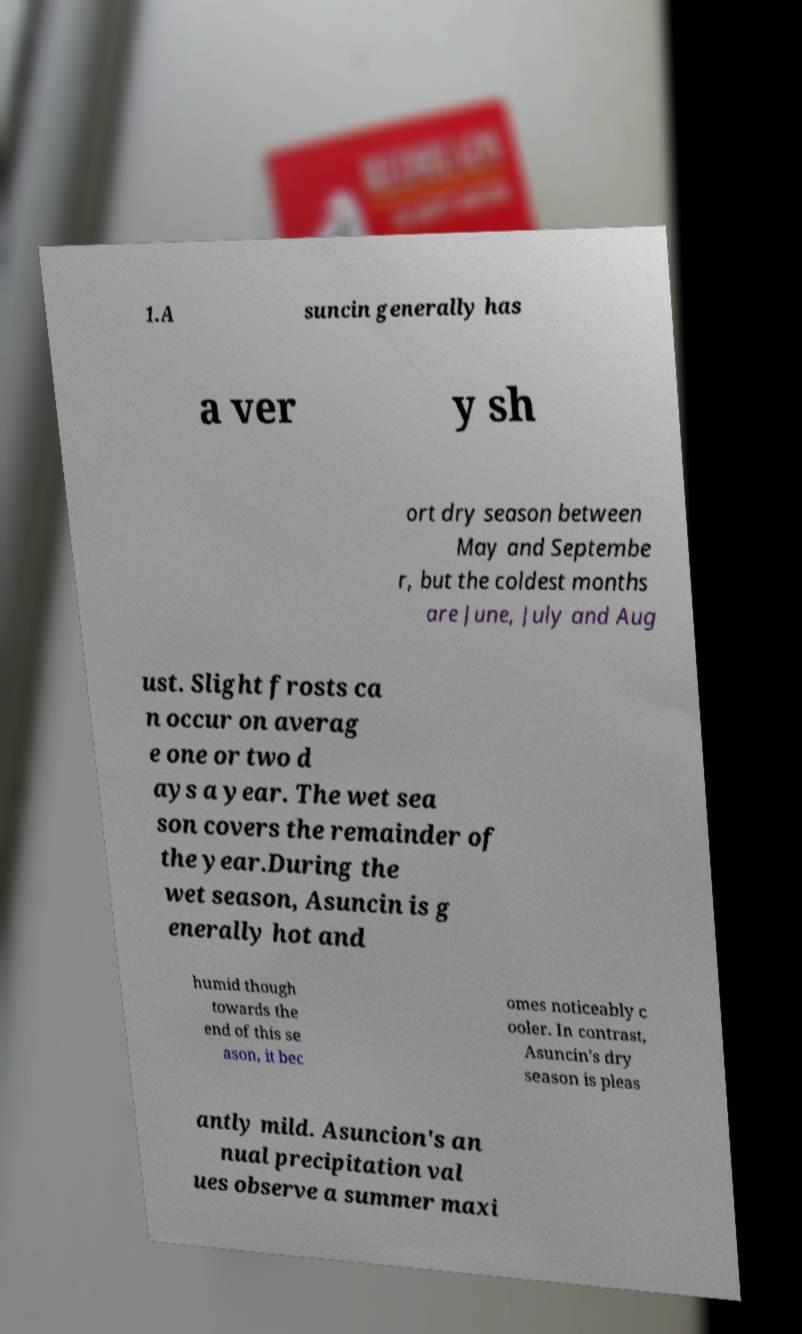I need the written content from this picture converted into text. Can you do that? 1.A suncin generally has a ver y sh ort dry season between May and Septembe r, but the coldest months are June, July and Aug ust. Slight frosts ca n occur on averag e one or two d ays a year. The wet sea son covers the remainder of the year.During the wet season, Asuncin is g enerally hot and humid though towards the end of this se ason, it bec omes noticeably c ooler. In contrast, Asuncin's dry season is pleas antly mild. Asuncion's an nual precipitation val ues observe a summer maxi 